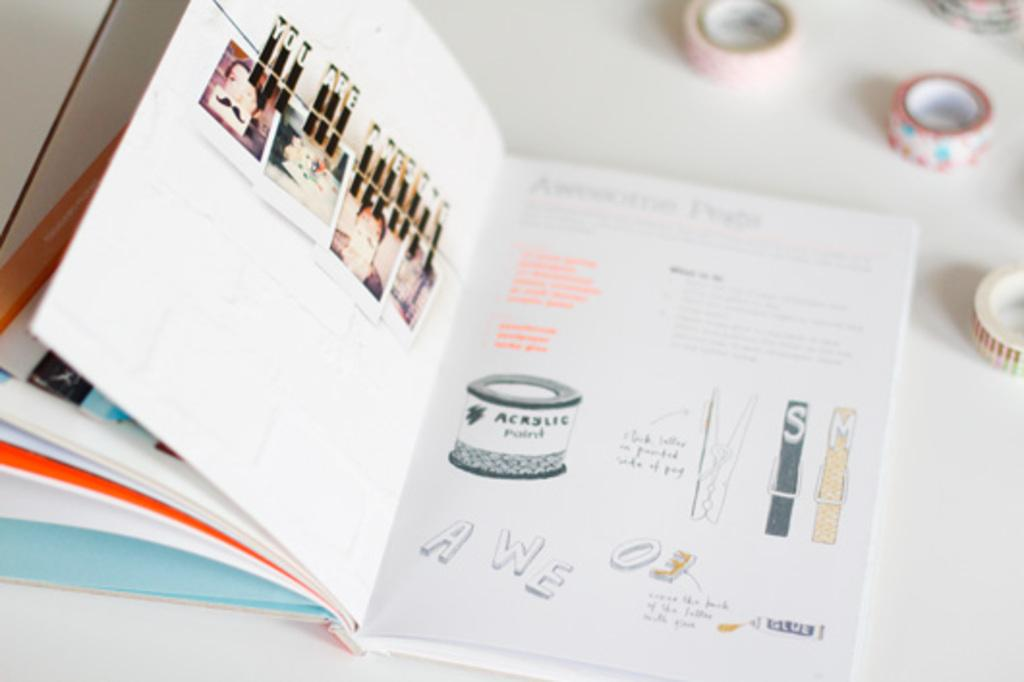<image>
Offer a succinct explanation of the picture presented. An acrylic paint can image is displayed on the page of a book. 